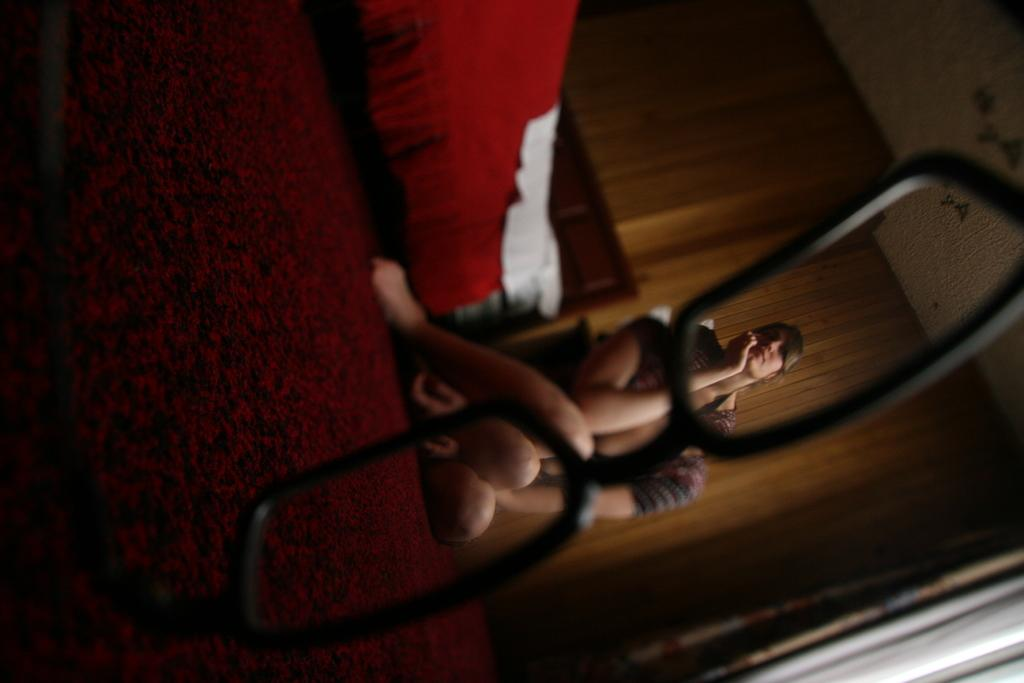What is the person in the image doing? The person is sitting on the floor in the image. What can be seen in the background of the image? There is a wooden wall in the background of the image. What is the color of the wooden wall? The wooden wall is in brown color. Can you see any rabbits in the image? There are no rabbits present in the image. What type of camera is being used to take the picture? The facts provided do not mention a camera, so it cannot be determined from the image. 